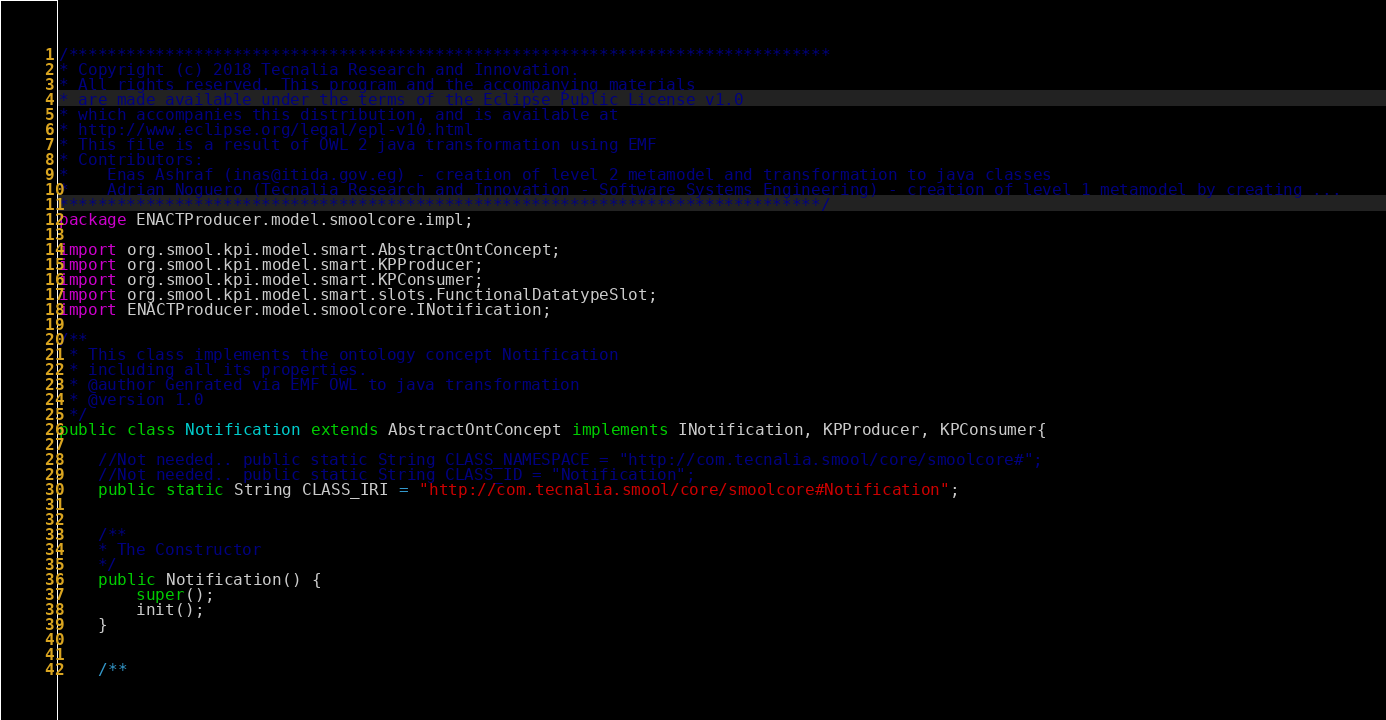<code> <loc_0><loc_0><loc_500><loc_500><_Java_>
/*******************************************************************************
* Copyright (c) 2018 Tecnalia Research and Innovation.
* All rights reserved. This program and the accompanying materials
* are made available under the terms of the Eclipse Public License v1.0
* which accompanies this distribution, and is available at
* http://www.eclipse.org/legal/epl-v10.html
* This file is a result of OWL 2 java transformation using EMF
* Contributors:
*    Enas Ashraf (inas@itida.gov.eg) - creation of level 2 metamodel and transformation to java classes 
*    Adrian Noguero (Tecnalia Research and Innovation - Software Systems Engineering) - creation of level 1 metamodel by creating ...
*******************************************************************************/ 
package ENACTProducer.model.smoolcore.impl;
     
import org.smool.kpi.model.smart.AbstractOntConcept;
import org.smool.kpi.model.smart.KPProducer;
import org.smool.kpi.model.smart.KPConsumer;
import org.smool.kpi.model.smart.slots.FunctionalDatatypeSlot;
import ENACTProducer.model.smoolcore.INotification;

/**
 * This class implements the ontology concept Notification
 * including all its properties.
 * @author Genrated via EMF OWL to java transformation
 * @version 1.0
 */
public class Notification extends AbstractOntConcept implements INotification, KPProducer, KPConsumer{

    //Not needed.. public static String CLASS_NAMESPACE = "http://com.tecnalia.smool/core/smoolcore#";
  	//Not needed.. public static String CLASS_ID = "Notification";
  	public static String CLASS_IRI = "http://com.tecnalia.smool/core/smoolcore#Notification"; 
  		
  		
  	/**
    * The Constructor
    */
    public Notification() {
    	super();
        init();
	}
    	
    	
	/**</code> 